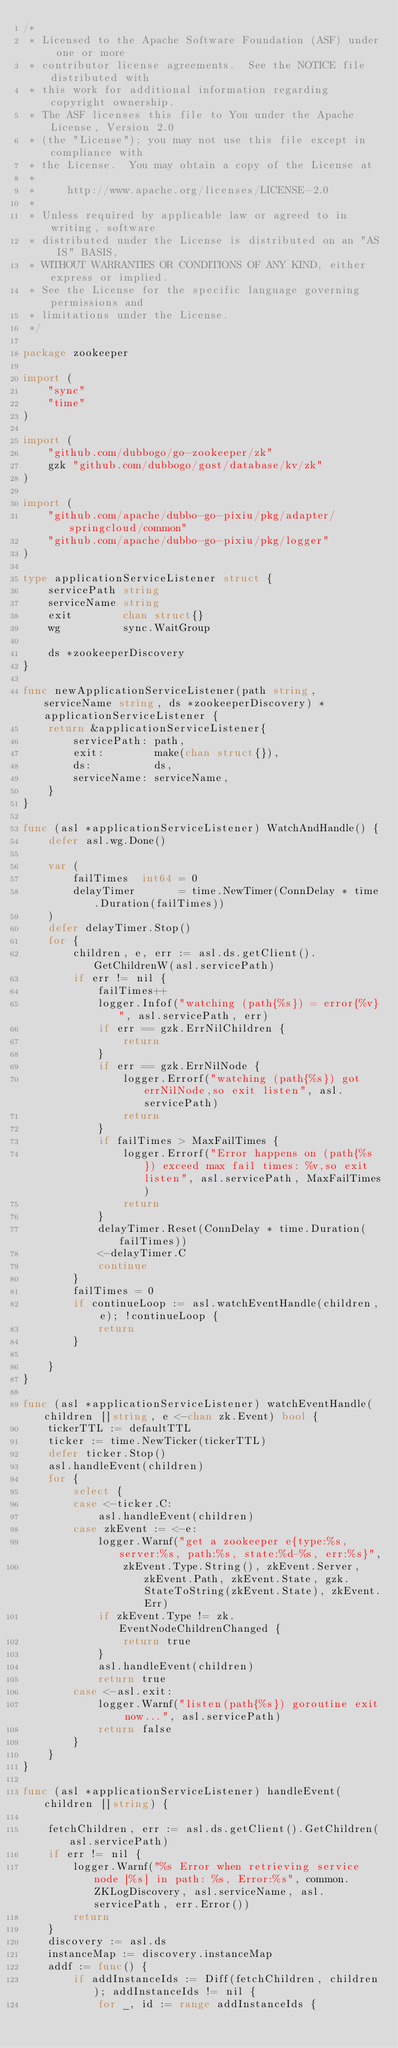<code> <loc_0><loc_0><loc_500><loc_500><_Go_>/*
 * Licensed to the Apache Software Foundation (ASF) under one or more
 * contributor license agreements.  See the NOTICE file distributed with
 * this work for additional information regarding copyright ownership.
 * The ASF licenses this file to You under the Apache License, Version 2.0
 * (the "License"); you may not use this file except in compliance with
 * the License.  You may obtain a copy of the License at
 *
 *     http://www.apache.org/licenses/LICENSE-2.0
 *
 * Unless required by applicable law or agreed to in writing, software
 * distributed under the License is distributed on an "AS IS" BASIS,
 * WITHOUT WARRANTIES OR CONDITIONS OF ANY KIND, either express or implied.
 * See the License for the specific language governing permissions and
 * limitations under the License.
 */

package zookeeper

import (
	"sync"
	"time"
)

import (
	"github.com/dubbogo/go-zookeeper/zk"
	gzk "github.com/dubbogo/gost/database/kv/zk"
)

import (
	"github.com/apache/dubbo-go-pixiu/pkg/adapter/springcloud/common"
	"github.com/apache/dubbo-go-pixiu/pkg/logger"
)

type applicationServiceListener struct {
	servicePath string
	serviceName string
	exit        chan struct{}
	wg          sync.WaitGroup

	ds *zookeeperDiscovery
}

func newApplicationServiceListener(path string, serviceName string, ds *zookeeperDiscovery) *applicationServiceListener {
	return &applicationServiceListener{
		servicePath: path,
		exit:        make(chan struct{}),
		ds:          ds,
		serviceName: serviceName,
	}
}

func (asl *applicationServiceListener) WatchAndHandle() {
	defer asl.wg.Done()

	var (
		failTimes  int64 = 0
		delayTimer       = time.NewTimer(ConnDelay * time.Duration(failTimes))
	)
	defer delayTimer.Stop()
	for {
		children, e, err := asl.ds.getClient().GetChildrenW(asl.servicePath)
		if err != nil {
			failTimes++
			logger.Infof("watching (path{%s}) = error{%v}", asl.servicePath, err)
			if err == gzk.ErrNilChildren {
				return
			}
			if err == gzk.ErrNilNode {
				logger.Errorf("watching (path{%s}) got errNilNode,so exit listen", asl.servicePath)
				return
			}
			if failTimes > MaxFailTimes {
				logger.Errorf("Error happens on (path{%s}) exceed max fail times: %v,so exit listen", asl.servicePath, MaxFailTimes)
				return
			}
			delayTimer.Reset(ConnDelay * time.Duration(failTimes))
			<-delayTimer.C
			continue
		}
		failTimes = 0
		if continueLoop := asl.watchEventHandle(children, e); !continueLoop {
			return
		}

	}
}

func (asl *applicationServiceListener) watchEventHandle(children []string, e <-chan zk.Event) bool {
	tickerTTL := defaultTTL
	ticker := time.NewTicker(tickerTTL)
	defer ticker.Stop()
	asl.handleEvent(children)
	for {
		select {
		case <-ticker.C:
			asl.handleEvent(children)
		case zkEvent := <-e:
			logger.Warnf("get a zookeeper e{type:%s, server:%s, path:%s, state:%d-%s, err:%s}",
				zkEvent.Type.String(), zkEvent.Server, zkEvent.Path, zkEvent.State, gzk.StateToString(zkEvent.State), zkEvent.Err)
			if zkEvent.Type != zk.EventNodeChildrenChanged {
				return true
			}
			asl.handleEvent(children)
			return true
		case <-asl.exit:
			logger.Warnf("listen(path{%s}) goroutine exit now...", asl.servicePath)
			return false
		}
	}
}

func (asl *applicationServiceListener) handleEvent(children []string) {

	fetchChildren, err := asl.ds.getClient().GetChildren(asl.servicePath)
	if err != nil {
		logger.Warnf("%s Error when retrieving service node [%s] in path: %s, Error:%s", common.ZKLogDiscovery, asl.serviceName, asl.servicePath, err.Error())
		return
	}
	discovery := asl.ds
	instanceMap := discovery.instanceMap
	addf := func() {
		if addInstanceIds := Diff(fetchChildren, children); addInstanceIds != nil {
			for _, id := range addInstanceIds {</code> 